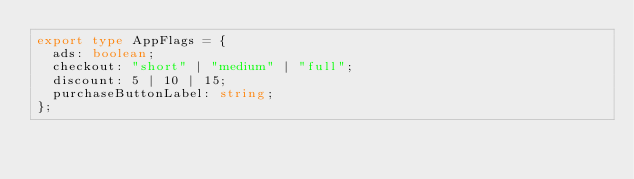Convert code to text. <code><loc_0><loc_0><loc_500><loc_500><_TypeScript_>export type AppFlags = {
  ads: boolean;
  checkout: "short" | "medium" | "full";
  discount: 5 | 10 | 15;
  purchaseButtonLabel: string;
};
</code> 